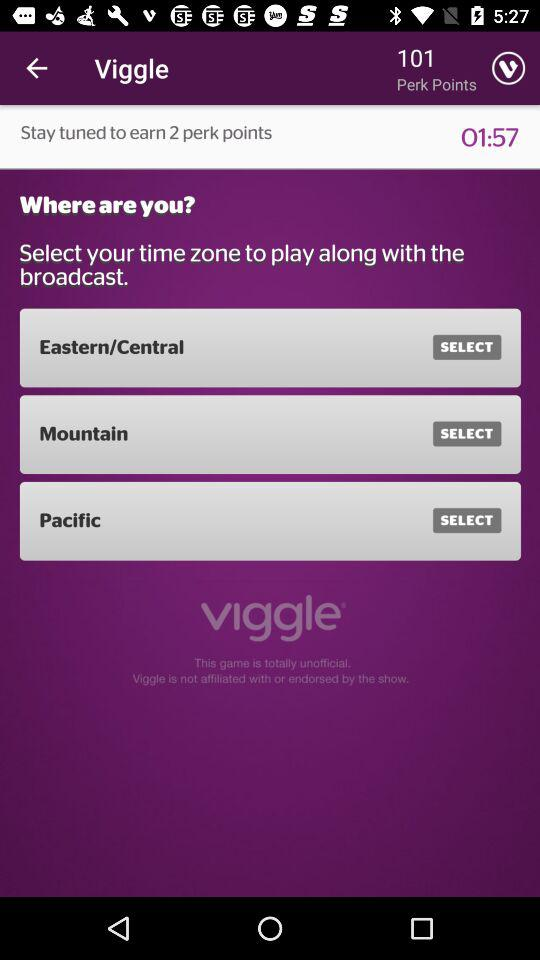How many time zones are available to select?
Answer the question using a single word or phrase. 3 